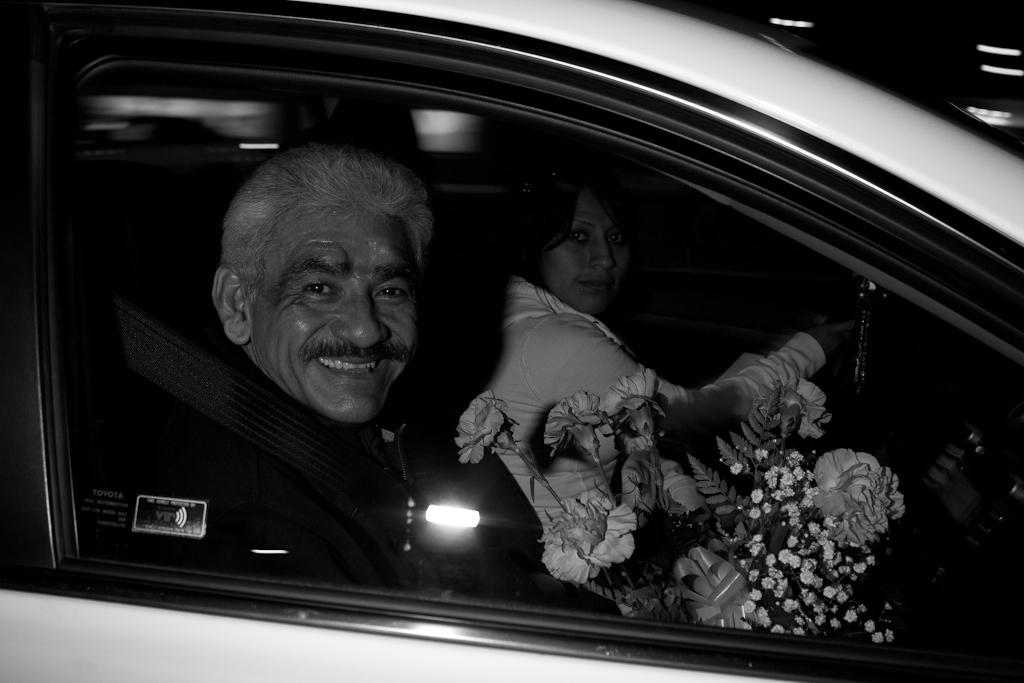How many people are in the car in the image? There are two people in the car in the image. What is the man holding in his hand? The man has flowers in his hand. How are the flowers described? The flowers are described as beautiful. How many children are visible in the image? There are no children visible in the image. What type of berry is the man holding in his hand? The man is not holding a berry; he is holding flowers. 